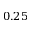Convert formula to latex. <formula><loc_0><loc_0><loc_500><loc_500>0 . 2 5</formula> 